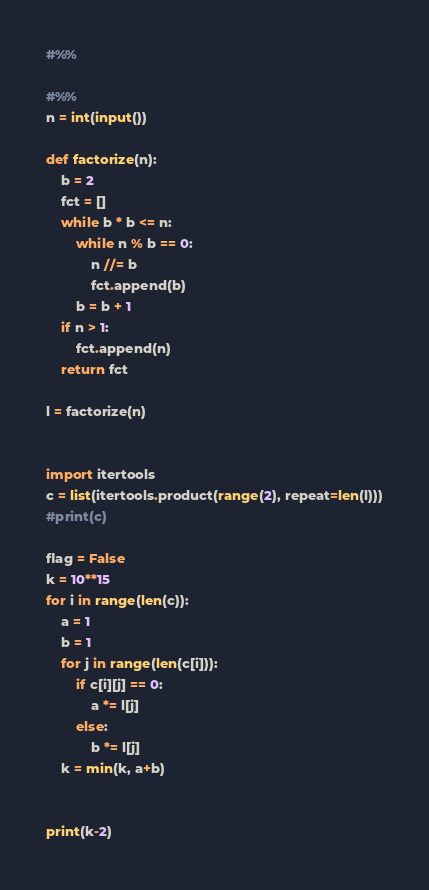<code> <loc_0><loc_0><loc_500><loc_500><_Python_>#%%

#%%
n = int(input())

def factorize(n):
    b = 2
    fct = []
    while b * b <= n:
        while n % b == 0:
            n //= b
            fct.append(b)
        b = b + 1
    if n > 1:
        fct.append(n)
    return fct

l = factorize(n)


import itertools
c = list(itertools.product(range(2), repeat=len(l)))
#print(c)

flag = False
k = 10**15
for i in range(len(c)):
    a = 1
    b = 1
    for j in range(len(c[i])):
        if c[i][j] == 0:
            a *= l[j]
        else:
            b *= l[j]
    k = min(k, a+b)
    

print(k-2)
</code> 